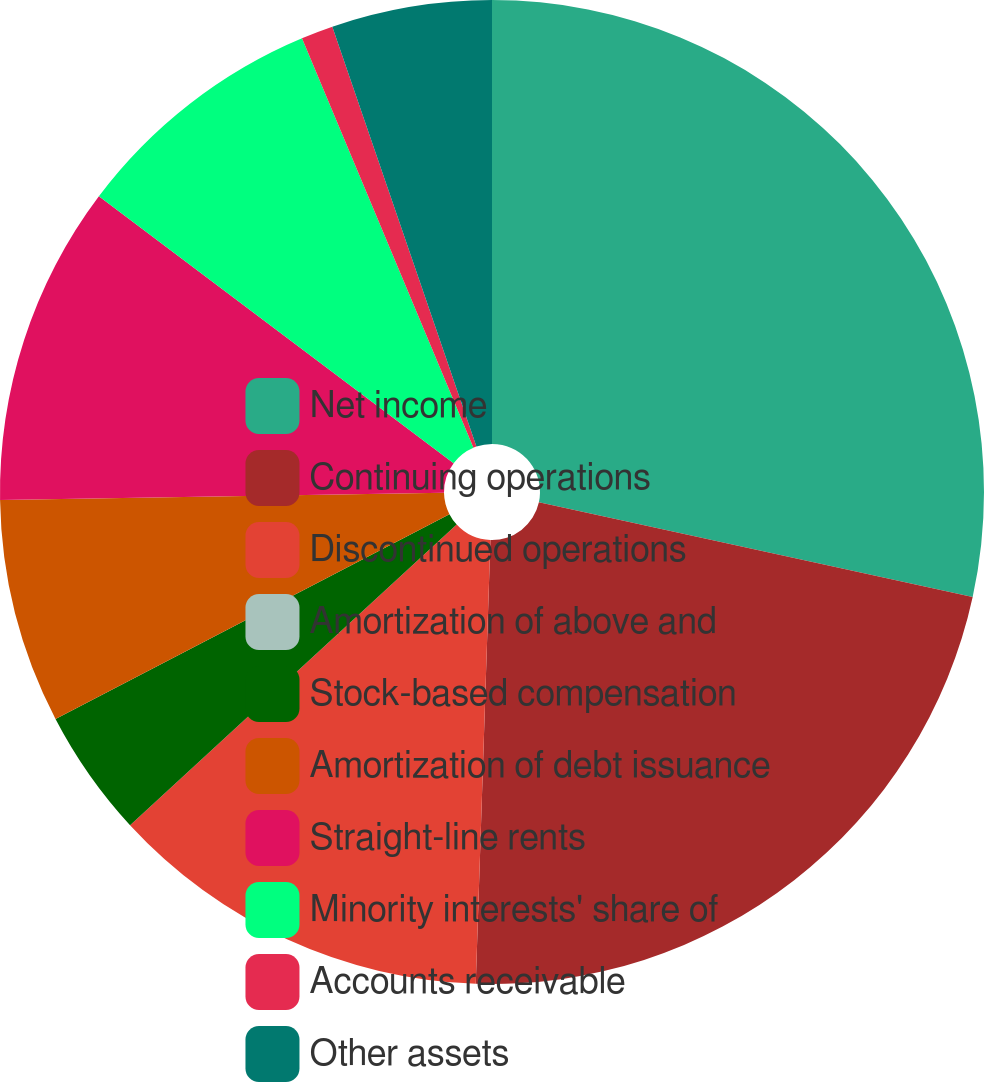Convert chart to OTSL. <chart><loc_0><loc_0><loc_500><loc_500><pie_chart><fcel>Net income<fcel>Continuing operations<fcel>Discontinued operations<fcel>Amortization of above and<fcel>Stock-based compensation<fcel>Amortization of debt issuance<fcel>Straight-line rents<fcel>Minority interests' share of<fcel>Accounts receivable<fcel>Other assets<nl><fcel>28.42%<fcel>22.1%<fcel>12.63%<fcel>0.0%<fcel>4.21%<fcel>7.37%<fcel>10.53%<fcel>8.42%<fcel>1.05%<fcel>5.26%<nl></chart> 